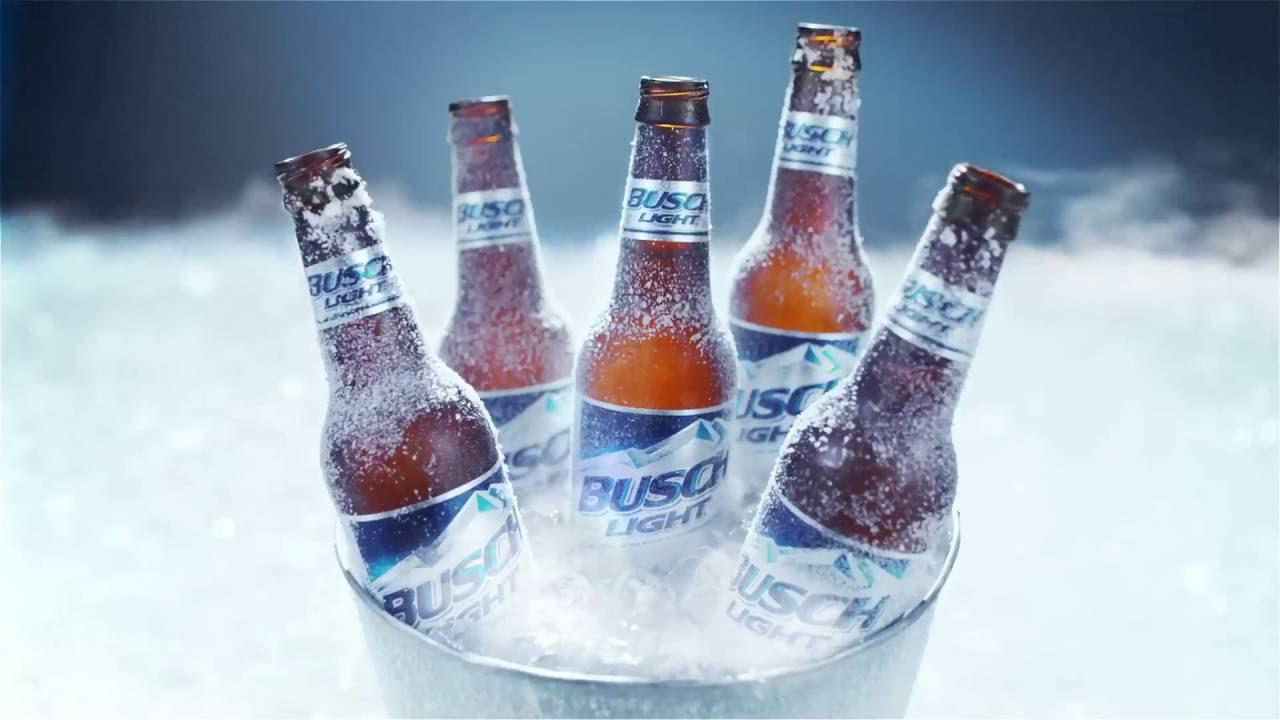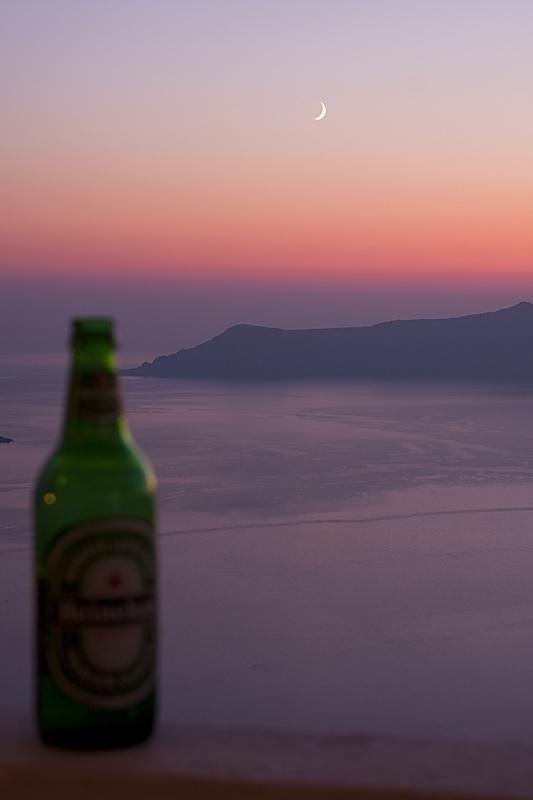The first image is the image on the left, the second image is the image on the right. Analyze the images presented: Is the assertion "One of the images shows exactly two bottles of beer." valid? Answer yes or no. No. The first image is the image on the left, the second image is the image on the right. Assess this claim about the two images: "All bottles have labels on the neck and the body.". Correct or not? Answer yes or no. Yes. 